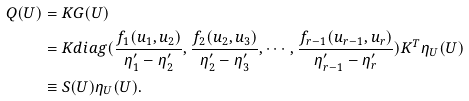Convert formula to latex. <formula><loc_0><loc_0><loc_500><loc_500>Q ( U ) & = K G ( U ) \\ & = K d i a g ( \frac { f _ { 1 } ( u _ { 1 } , u _ { 2 } ) } { \eta ^ { \prime } _ { 1 } - \eta ^ { \prime } _ { 2 } } , \frac { f _ { 2 } ( u _ { 2 } , u _ { 3 } ) } { \eta ^ { \prime } _ { 2 } - \eta ^ { \prime } _ { 3 } } , \cdots , \frac { f _ { r - 1 } ( u _ { r - 1 } , u _ { r } ) } { \eta ^ { \prime } _ { r - 1 } - \eta ^ { \prime } _ { r } } ) K ^ { T } \eta _ { U } ( U ) \\ & \equiv S ( U ) \eta _ { U } ( U ) .</formula> 